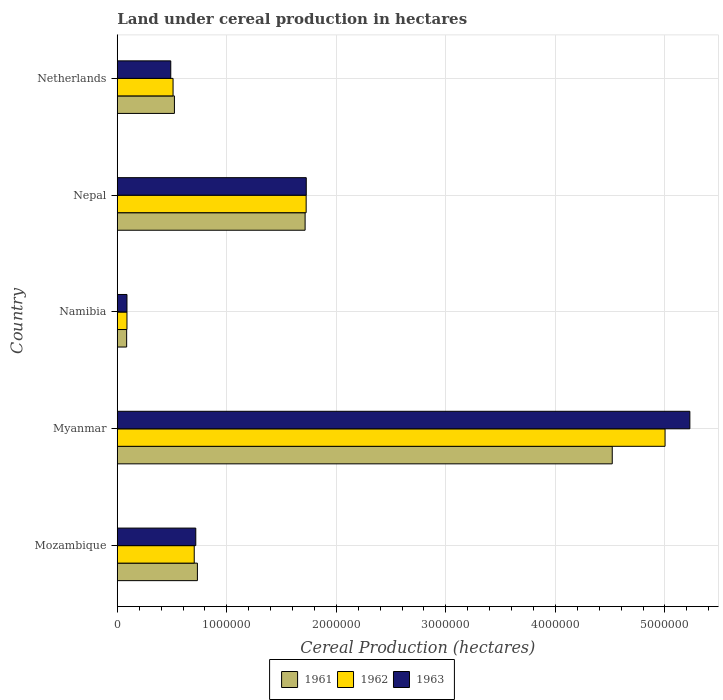Are the number of bars per tick equal to the number of legend labels?
Your answer should be compact. Yes. Are the number of bars on each tick of the Y-axis equal?
Offer a terse response. Yes. How many bars are there on the 1st tick from the top?
Provide a short and direct response. 3. In how many cases, is the number of bars for a given country not equal to the number of legend labels?
Make the answer very short. 0. What is the land under cereal production in 1961 in Nepal?
Keep it short and to the point. 1.72e+06. Across all countries, what is the maximum land under cereal production in 1961?
Provide a short and direct response. 4.52e+06. Across all countries, what is the minimum land under cereal production in 1963?
Offer a terse response. 8.84e+04. In which country was the land under cereal production in 1963 maximum?
Keep it short and to the point. Myanmar. In which country was the land under cereal production in 1961 minimum?
Give a very brief answer. Namibia. What is the total land under cereal production in 1963 in the graph?
Your response must be concise. 8.25e+06. What is the difference between the land under cereal production in 1963 in Mozambique and that in Namibia?
Ensure brevity in your answer.  6.28e+05. What is the difference between the land under cereal production in 1963 in Namibia and the land under cereal production in 1961 in Mozambique?
Offer a terse response. -6.43e+05. What is the average land under cereal production in 1961 per country?
Your answer should be very brief. 1.51e+06. What is the difference between the land under cereal production in 1961 and land under cereal production in 1963 in Namibia?
Make the answer very short. -2850. What is the ratio of the land under cereal production in 1961 in Myanmar to that in Nepal?
Offer a terse response. 2.64. Is the land under cereal production in 1961 in Mozambique less than that in Namibia?
Make the answer very short. No. What is the difference between the highest and the second highest land under cereal production in 1961?
Offer a terse response. 2.80e+06. What is the difference between the highest and the lowest land under cereal production in 1961?
Offer a terse response. 4.43e+06. In how many countries, is the land under cereal production in 1962 greater than the average land under cereal production in 1962 taken over all countries?
Give a very brief answer. 2. Is the sum of the land under cereal production in 1961 in Nepal and Netherlands greater than the maximum land under cereal production in 1963 across all countries?
Provide a succinct answer. No. Where does the legend appear in the graph?
Your answer should be very brief. Bottom center. How many legend labels are there?
Ensure brevity in your answer.  3. What is the title of the graph?
Your answer should be very brief. Land under cereal production in hectares. What is the label or title of the X-axis?
Provide a short and direct response. Cereal Production (hectares). What is the Cereal Production (hectares) in 1961 in Mozambique?
Make the answer very short. 7.32e+05. What is the Cereal Production (hectares) in 1962 in Mozambique?
Keep it short and to the point. 7.03e+05. What is the Cereal Production (hectares) in 1963 in Mozambique?
Your answer should be very brief. 7.17e+05. What is the Cereal Production (hectares) in 1961 in Myanmar?
Ensure brevity in your answer.  4.52e+06. What is the Cereal Production (hectares) in 1962 in Myanmar?
Make the answer very short. 5.00e+06. What is the Cereal Production (hectares) of 1963 in Myanmar?
Your response must be concise. 5.23e+06. What is the Cereal Production (hectares) of 1961 in Namibia?
Provide a short and direct response. 8.56e+04. What is the Cereal Production (hectares) of 1962 in Namibia?
Your response must be concise. 8.84e+04. What is the Cereal Production (hectares) of 1963 in Namibia?
Your answer should be compact. 8.84e+04. What is the Cereal Production (hectares) in 1961 in Nepal?
Offer a very short reply. 1.72e+06. What is the Cereal Production (hectares) of 1962 in Nepal?
Your answer should be very brief. 1.72e+06. What is the Cereal Production (hectares) of 1963 in Nepal?
Ensure brevity in your answer.  1.73e+06. What is the Cereal Production (hectares) in 1961 in Netherlands?
Make the answer very short. 5.22e+05. What is the Cereal Production (hectares) in 1962 in Netherlands?
Offer a terse response. 5.09e+05. What is the Cereal Production (hectares) of 1963 in Netherlands?
Your answer should be compact. 4.88e+05. Across all countries, what is the maximum Cereal Production (hectares) in 1961?
Offer a very short reply. 4.52e+06. Across all countries, what is the maximum Cereal Production (hectares) of 1962?
Your response must be concise. 5.00e+06. Across all countries, what is the maximum Cereal Production (hectares) of 1963?
Provide a succinct answer. 5.23e+06. Across all countries, what is the minimum Cereal Production (hectares) in 1961?
Your answer should be very brief. 8.56e+04. Across all countries, what is the minimum Cereal Production (hectares) in 1962?
Keep it short and to the point. 8.84e+04. Across all countries, what is the minimum Cereal Production (hectares) in 1963?
Make the answer very short. 8.84e+04. What is the total Cereal Production (hectares) of 1961 in the graph?
Your answer should be very brief. 7.57e+06. What is the total Cereal Production (hectares) of 1962 in the graph?
Offer a very short reply. 8.03e+06. What is the total Cereal Production (hectares) in 1963 in the graph?
Your response must be concise. 8.25e+06. What is the difference between the Cereal Production (hectares) of 1961 in Mozambique and that in Myanmar?
Make the answer very short. -3.79e+06. What is the difference between the Cereal Production (hectares) in 1962 in Mozambique and that in Myanmar?
Provide a short and direct response. -4.30e+06. What is the difference between the Cereal Production (hectares) of 1963 in Mozambique and that in Myanmar?
Offer a terse response. -4.51e+06. What is the difference between the Cereal Production (hectares) of 1961 in Mozambique and that in Namibia?
Ensure brevity in your answer.  6.46e+05. What is the difference between the Cereal Production (hectares) of 1962 in Mozambique and that in Namibia?
Provide a short and direct response. 6.14e+05. What is the difference between the Cereal Production (hectares) of 1963 in Mozambique and that in Namibia?
Offer a very short reply. 6.28e+05. What is the difference between the Cereal Production (hectares) in 1961 in Mozambique and that in Nepal?
Provide a short and direct response. -9.84e+05. What is the difference between the Cereal Production (hectares) of 1962 in Mozambique and that in Nepal?
Your answer should be compact. -1.02e+06. What is the difference between the Cereal Production (hectares) of 1963 in Mozambique and that in Nepal?
Offer a terse response. -1.01e+06. What is the difference between the Cereal Production (hectares) of 1961 in Mozambique and that in Netherlands?
Make the answer very short. 2.10e+05. What is the difference between the Cereal Production (hectares) of 1962 in Mozambique and that in Netherlands?
Make the answer very short. 1.93e+05. What is the difference between the Cereal Production (hectares) in 1963 in Mozambique and that in Netherlands?
Give a very brief answer. 2.28e+05. What is the difference between the Cereal Production (hectares) in 1961 in Myanmar and that in Namibia?
Provide a succinct answer. 4.43e+06. What is the difference between the Cereal Production (hectares) of 1962 in Myanmar and that in Namibia?
Provide a short and direct response. 4.91e+06. What is the difference between the Cereal Production (hectares) of 1963 in Myanmar and that in Namibia?
Offer a terse response. 5.14e+06. What is the difference between the Cereal Production (hectares) in 1961 in Myanmar and that in Nepal?
Offer a terse response. 2.80e+06. What is the difference between the Cereal Production (hectares) of 1962 in Myanmar and that in Nepal?
Your response must be concise. 3.28e+06. What is the difference between the Cereal Production (hectares) in 1963 in Myanmar and that in Nepal?
Make the answer very short. 3.50e+06. What is the difference between the Cereal Production (hectares) in 1961 in Myanmar and that in Netherlands?
Offer a terse response. 4.00e+06. What is the difference between the Cereal Production (hectares) of 1962 in Myanmar and that in Netherlands?
Give a very brief answer. 4.49e+06. What is the difference between the Cereal Production (hectares) in 1963 in Myanmar and that in Netherlands?
Your answer should be compact. 4.74e+06. What is the difference between the Cereal Production (hectares) of 1961 in Namibia and that in Nepal?
Keep it short and to the point. -1.63e+06. What is the difference between the Cereal Production (hectares) in 1962 in Namibia and that in Nepal?
Ensure brevity in your answer.  -1.64e+06. What is the difference between the Cereal Production (hectares) in 1963 in Namibia and that in Nepal?
Give a very brief answer. -1.64e+06. What is the difference between the Cereal Production (hectares) of 1961 in Namibia and that in Netherlands?
Make the answer very short. -4.36e+05. What is the difference between the Cereal Production (hectares) in 1962 in Namibia and that in Netherlands?
Provide a short and direct response. -4.21e+05. What is the difference between the Cereal Production (hectares) of 1963 in Namibia and that in Netherlands?
Offer a terse response. -4.00e+05. What is the difference between the Cereal Production (hectares) in 1961 in Nepal and that in Netherlands?
Your answer should be compact. 1.19e+06. What is the difference between the Cereal Production (hectares) in 1962 in Nepal and that in Netherlands?
Ensure brevity in your answer.  1.22e+06. What is the difference between the Cereal Production (hectares) in 1963 in Nepal and that in Netherlands?
Your response must be concise. 1.24e+06. What is the difference between the Cereal Production (hectares) of 1961 in Mozambique and the Cereal Production (hectares) of 1962 in Myanmar?
Offer a very short reply. -4.27e+06. What is the difference between the Cereal Production (hectares) in 1961 in Mozambique and the Cereal Production (hectares) in 1963 in Myanmar?
Provide a short and direct response. -4.50e+06. What is the difference between the Cereal Production (hectares) in 1962 in Mozambique and the Cereal Production (hectares) in 1963 in Myanmar?
Your answer should be very brief. -4.53e+06. What is the difference between the Cereal Production (hectares) in 1961 in Mozambique and the Cereal Production (hectares) in 1962 in Namibia?
Make the answer very short. 6.43e+05. What is the difference between the Cereal Production (hectares) of 1961 in Mozambique and the Cereal Production (hectares) of 1963 in Namibia?
Your answer should be very brief. 6.43e+05. What is the difference between the Cereal Production (hectares) of 1962 in Mozambique and the Cereal Production (hectares) of 1963 in Namibia?
Provide a succinct answer. 6.14e+05. What is the difference between the Cereal Production (hectares) in 1961 in Mozambique and the Cereal Production (hectares) in 1962 in Nepal?
Provide a succinct answer. -9.93e+05. What is the difference between the Cereal Production (hectares) of 1961 in Mozambique and the Cereal Production (hectares) of 1963 in Nepal?
Your answer should be compact. -9.94e+05. What is the difference between the Cereal Production (hectares) of 1962 in Mozambique and the Cereal Production (hectares) of 1963 in Nepal?
Provide a succinct answer. -1.02e+06. What is the difference between the Cereal Production (hectares) of 1961 in Mozambique and the Cereal Production (hectares) of 1962 in Netherlands?
Give a very brief answer. 2.22e+05. What is the difference between the Cereal Production (hectares) of 1961 in Mozambique and the Cereal Production (hectares) of 1963 in Netherlands?
Your answer should be compact. 2.43e+05. What is the difference between the Cereal Production (hectares) in 1962 in Mozambique and the Cereal Production (hectares) in 1963 in Netherlands?
Keep it short and to the point. 2.14e+05. What is the difference between the Cereal Production (hectares) of 1961 in Myanmar and the Cereal Production (hectares) of 1962 in Namibia?
Keep it short and to the point. 4.43e+06. What is the difference between the Cereal Production (hectares) of 1961 in Myanmar and the Cereal Production (hectares) of 1963 in Namibia?
Provide a succinct answer. 4.43e+06. What is the difference between the Cereal Production (hectares) of 1962 in Myanmar and the Cereal Production (hectares) of 1963 in Namibia?
Ensure brevity in your answer.  4.91e+06. What is the difference between the Cereal Production (hectares) in 1961 in Myanmar and the Cereal Production (hectares) in 1962 in Nepal?
Make the answer very short. 2.79e+06. What is the difference between the Cereal Production (hectares) of 1961 in Myanmar and the Cereal Production (hectares) of 1963 in Nepal?
Offer a terse response. 2.79e+06. What is the difference between the Cereal Production (hectares) in 1962 in Myanmar and the Cereal Production (hectares) in 1963 in Nepal?
Ensure brevity in your answer.  3.28e+06. What is the difference between the Cereal Production (hectares) of 1961 in Myanmar and the Cereal Production (hectares) of 1962 in Netherlands?
Keep it short and to the point. 4.01e+06. What is the difference between the Cereal Production (hectares) of 1961 in Myanmar and the Cereal Production (hectares) of 1963 in Netherlands?
Your answer should be very brief. 4.03e+06. What is the difference between the Cereal Production (hectares) in 1962 in Myanmar and the Cereal Production (hectares) in 1963 in Netherlands?
Your answer should be compact. 4.51e+06. What is the difference between the Cereal Production (hectares) of 1961 in Namibia and the Cereal Production (hectares) of 1962 in Nepal?
Provide a short and direct response. -1.64e+06. What is the difference between the Cereal Production (hectares) in 1961 in Namibia and the Cereal Production (hectares) in 1963 in Nepal?
Keep it short and to the point. -1.64e+06. What is the difference between the Cereal Production (hectares) of 1962 in Namibia and the Cereal Production (hectares) of 1963 in Nepal?
Your answer should be compact. -1.64e+06. What is the difference between the Cereal Production (hectares) of 1961 in Namibia and the Cereal Production (hectares) of 1962 in Netherlands?
Provide a short and direct response. -4.24e+05. What is the difference between the Cereal Production (hectares) of 1961 in Namibia and the Cereal Production (hectares) of 1963 in Netherlands?
Your answer should be compact. -4.03e+05. What is the difference between the Cereal Production (hectares) in 1962 in Namibia and the Cereal Production (hectares) in 1963 in Netherlands?
Offer a terse response. -4.00e+05. What is the difference between the Cereal Production (hectares) of 1961 in Nepal and the Cereal Production (hectares) of 1962 in Netherlands?
Your response must be concise. 1.21e+06. What is the difference between the Cereal Production (hectares) in 1961 in Nepal and the Cereal Production (hectares) in 1963 in Netherlands?
Your answer should be compact. 1.23e+06. What is the difference between the Cereal Production (hectares) in 1962 in Nepal and the Cereal Production (hectares) in 1963 in Netherlands?
Provide a short and direct response. 1.24e+06. What is the average Cereal Production (hectares) in 1961 per country?
Your answer should be compact. 1.51e+06. What is the average Cereal Production (hectares) of 1962 per country?
Offer a very short reply. 1.61e+06. What is the average Cereal Production (hectares) in 1963 per country?
Your response must be concise. 1.65e+06. What is the difference between the Cereal Production (hectares) in 1961 and Cereal Production (hectares) in 1962 in Mozambique?
Your response must be concise. 2.89e+04. What is the difference between the Cereal Production (hectares) of 1961 and Cereal Production (hectares) of 1963 in Mozambique?
Make the answer very short. 1.48e+04. What is the difference between the Cereal Production (hectares) of 1962 and Cereal Production (hectares) of 1963 in Mozambique?
Offer a terse response. -1.41e+04. What is the difference between the Cereal Production (hectares) of 1961 and Cereal Production (hectares) of 1962 in Myanmar?
Offer a very short reply. -4.82e+05. What is the difference between the Cereal Production (hectares) of 1961 and Cereal Production (hectares) of 1963 in Myanmar?
Your response must be concise. -7.09e+05. What is the difference between the Cereal Production (hectares) of 1962 and Cereal Production (hectares) of 1963 in Myanmar?
Your answer should be very brief. -2.27e+05. What is the difference between the Cereal Production (hectares) in 1961 and Cereal Production (hectares) in 1962 in Namibia?
Your answer should be very brief. -2800. What is the difference between the Cereal Production (hectares) of 1961 and Cereal Production (hectares) of 1963 in Namibia?
Keep it short and to the point. -2850. What is the difference between the Cereal Production (hectares) in 1962 and Cereal Production (hectares) in 1963 in Namibia?
Provide a succinct answer. -50. What is the difference between the Cereal Production (hectares) in 1961 and Cereal Production (hectares) in 1962 in Nepal?
Ensure brevity in your answer.  -9500. What is the difference between the Cereal Production (hectares) of 1961 and Cereal Production (hectares) of 1963 in Nepal?
Offer a terse response. -1.05e+04. What is the difference between the Cereal Production (hectares) in 1962 and Cereal Production (hectares) in 1963 in Nepal?
Keep it short and to the point. -1000. What is the difference between the Cereal Production (hectares) in 1961 and Cereal Production (hectares) in 1962 in Netherlands?
Your response must be concise. 1.25e+04. What is the difference between the Cereal Production (hectares) in 1961 and Cereal Production (hectares) in 1963 in Netherlands?
Provide a succinct answer. 3.34e+04. What is the difference between the Cereal Production (hectares) in 1962 and Cereal Production (hectares) in 1963 in Netherlands?
Make the answer very short. 2.09e+04. What is the ratio of the Cereal Production (hectares) in 1961 in Mozambique to that in Myanmar?
Give a very brief answer. 0.16. What is the ratio of the Cereal Production (hectares) of 1962 in Mozambique to that in Myanmar?
Give a very brief answer. 0.14. What is the ratio of the Cereal Production (hectares) of 1963 in Mozambique to that in Myanmar?
Your response must be concise. 0.14. What is the ratio of the Cereal Production (hectares) of 1961 in Mozambique to that in Namibia?
Offer a very short reply. 8.55. What is the ratio of the Cereal Production (hectares) of 1962 in Mozambique to that in Namibia?
Make the answer very short. 7.95. What is the ratio of the Cereal Production (hectares) in 1963 in Mozambique to that in Namibia?
Make the answer very short. 8.1. What is the ratio of the Cereal Production (hectares) in 1961 in Mozambique to that in Nepal?
Provide a succinct answer. 0.43. What is the ratio of the Cereal Production (hectares) in 1962 in Mozambique to that in Nepal?
Make the answer very short. 0.41. What is the ratio of the Cereal Production (hectares) of 1963 in Mozambique to that in Nepal?
Ensure brevity in your answer.  0.42. What is the ratio of the Cereal Production (hectares) in 1961 in Mozambique to that in Netherlands?
Ensure brevity in your answer.  1.4. What is the ratio of the Cereal Production (hectares) of 1962 in Mozambique to that in Netherlands?
Your answer should be compact. 1.38. What is the ratio of the Cereal Production (hectares) of 1963 in Mozambique to that in Netherlands?
Keep it short and to the point. 1.47. What is the ratio of the Cereal Production (hectares) in 1961 in Myanmar to that in Namibia?
Your response must be concise. 52.8. What is the ratio of the Cereal Production (hectares) in 1962 in Myanmar to that in Namibia?
Your answer should be very brief. 56.58. What is the ratio of the Cereal Production (hectares) of 1963 in Myanmar to that in Namibia?
Offer a very short reply. 59.11. What is the ratio of the Cereal Production (hectares) in 1961 in Myanmar to that in Nepal?
Give a very brief answer. 2.64. What is the ratio of the Cereal Production (hectares) of 1962 in Myanmar to that in Nepal?
Ensure brevity in your answer.  2.9. What is the ratio of the Cereal Production (hectares) in 1963 in Myanmar to that in Nepal?
Your answer should be compact. 3.03. What is the ratio of the Cereal Production (hectares) of 1961 in Myanmar to that in Netherlands?
Offer a very short reply. 8.66. What is the ratio of the Cereal Production (hectares) of 1962 in Myanmar to that in Netherlands?
Keep it short and to the point. 9.82. What is the ratio of the Cereal Production (hectares) in 1963 in Myanmar to that in Netherlands?
Your answer should be very brief. 10.7. What is the ratio of the Cereal Production (hectares) of 1961 in Namibia to that in Nepal?
Your answer should be very brief. 0.05. What is the ratio of the Cereal Production (hectares) in 1962 in Namibia to that in Nepal?
Your answer should be compact. 0.05. What is the ratio of the Cereal Production (hectares) in 1963 in Namibia to that in Nepal?
Provide a succinct answer. 0.05. What is the ratio of the Cereal Production (hectares) of 1961 in Namibia to that in Netherlands?
Provide a succinct answer. 0.16. What is the ratio of the Cereal Production (hectares) in 1962 in Namibia to that in Netherlands?
Give a very brief answer. 0.17. What is the ratio of the Cereal Production (hectares) in 1963 in Namibia to that in Netherlands?
Your answer should be compact. 0.18. What is the ratio of the Cereal Production (hectares) in 1961 in Nepal to that in Netherlands?
Offer a terse response. 3.29. What is the ratio of the Cereal Production (hectares) of 1962 in Nepal to that in Netherlands?
Your answer should be compact. 3.39. What is the ratio of the Cereal Production (hectares) in 1963 in Nepal to that in Netherlands?
Keep it short and to the point. 3.53. What is the difference between the highest and the second highest Cereal Production (hectares) of 1961?
Keep it short and to the point. 2.80e+06. What is the difference between the highest and the second highest Cereal Production (hectares) in 1962?
Provide a short and direct response. 3.28e+06. What is the difference between the highest and the second highest Cereal Production (hectares) of 1963?
Offer a terse response. 3.50e+06. What is the difference between the highest and the lowest Cereal Production (hectares) in 1961?
Offer a very short reply. 4.43e+06. What is the difference between the highest and the lowest Cereal Production (hectares) in 1962?
Your response must be concise. 4.91e+06. What is the difference between the highest and the lowest Cereal Production (hectares) in 1963?
Provide a succinct answer. 5.14e+06. 